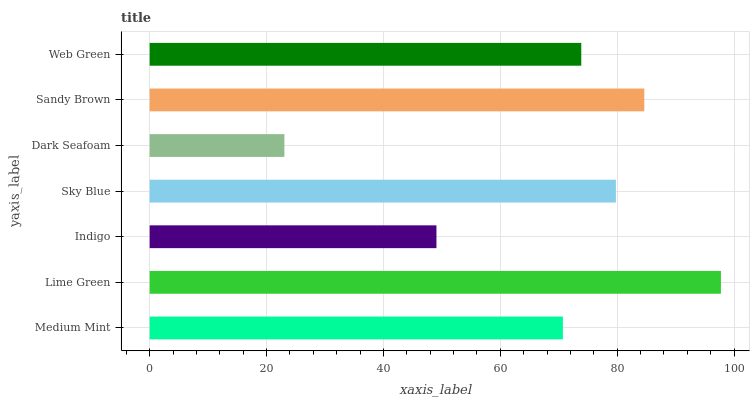Is Dark Seafoam the minimum?
Answer yes or no. Yes. Is Lime Green the maximum?
Answer yes or no. Yes. Is Indigo the minimum?
Answer yes or no. No. Is Indigo the maximum?
Answer yes or no. No. Is Lime Green greater than Indigo?
Answer yes or no. Yes. Is Indigo less than Lime Green?
Answer yes or no. Yes. Is Indigo greater than Lime Green?
Answer yes or no. No. Is Lime Green less than Indigo?
Answer yes or no. No. Is Web Green the high median?
Answer yes or no. Yes. Is Web Green the low median?
Answer yes or no. Yes. Is Indigo the high median?
Answer yes or no. No. Is Indigo the low median?
Answer yes or no. No. 